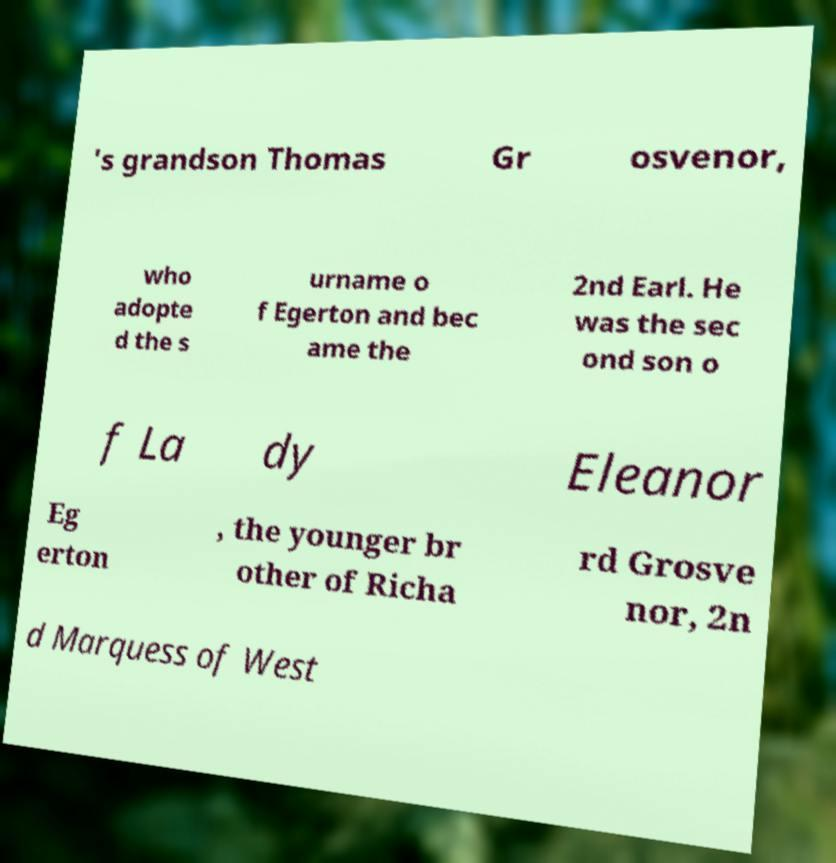What messages or text are displayed in this image? I need them in a readable, typed format. 's grandson Thomas Gr osvenor, who adopte d the s urname o f Egerton and bec ame the 2nd Earl. He was the sec ond son o f La dy Eleanor Eg erton , the younger br other of Richa rd Grosve nor, 2n d Marquess of West 